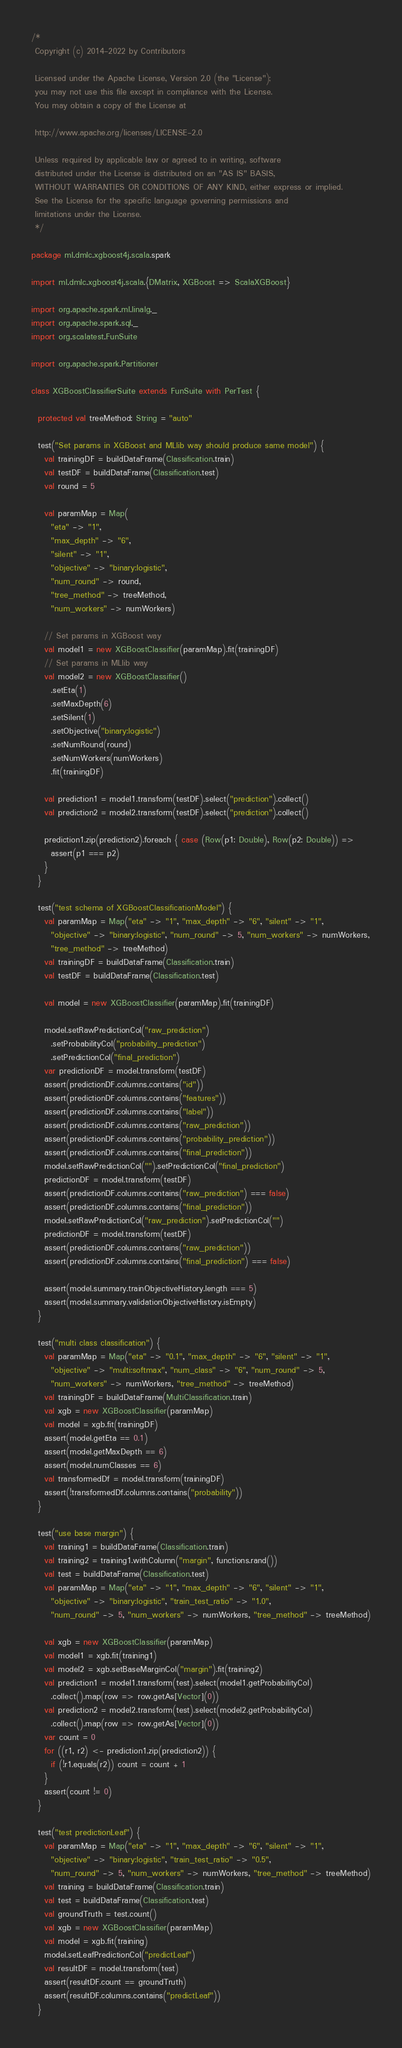<code> <loc_0><loc_0><loc_500><loc_500><_Scala_>/*
 Copyright (c) 2014-2022 by Contributors

 Licensed under the Apache License, Version 2.0 (the "License");
 you may not use this file except in compliance with the License.
 You may obtain a copy of the License at

 http://www.apache.org/licenses/LICENSE-2.0

 Unless required by applicable law or agreed to in writing, software
 distributed under the License is distributed on an "AS IS" BASIS,
 WITHOUT WARRANTIES OR CONDITIONS OF ANY KIND, either express or implied.
 See the License for the specific language governing permissions and
 limitations under the License.
 */

package ml.dmlc.xgboost4j.scala.spark

import ml.dmlc.xgboost4j.scala.{DMatrix, XGBoost => ScalaXGBoost}

import org.apache.spark.ml.linalg._
import org.apache.spark.sql._
import org.scalatest.FunSuite

import org.apache.spark.Partitioner

class XGBoostClassifierSuite extends FunSuite with PerTest {

  protected val treeMethod: String = "auto"

  test("Set params in XGBoost and MLlib way should produce same model") {
    val trainingDF = buildDataFrame(Classification.train)
    val testDF = buildDataFrame(Classification.test)
    val round = 5

    val paramMap = Map(
      "eta" -> "1",
      "max_depth" -> "6",
      "silent" -> "1",
      "objective" -> "binary:logistic",
      "num_round" -> round,
      "tree_method" -> treeMethod,
      "num_workers" -> numWorkers)

    // Set params in XGBoost way
    val model1 = new XGBoostClassifier(paramMap).fit(trainingDF)
    // Set params in MLlib way
    val model2 = new XGBoostClassifier()
      .setEta(1)
      .setMaxDepth(6)
      .setSilent(1)
      .setObjective("binary:logistic")
      .setNumRound(round)
      .setNumWorkers(numWorkers)
      .fit(trainingDF)

    val prediction1 = model1.transform(testDF).select("prediction").collect()
    val prediction2 = model2.transform(testDF).select("prediction").collect()

    prediction1.zip(prediction2).foreach { case (Row(p1: Double), Row(p2: Double)) =>
      assert(p1 === p2)
    }
  }

  test("test schema of XGBoostClassificationModel") {
    val paramMap = Map("eta" -> "1", "max_depth" -> "6", "silent" -> "1",
      "objective" -> "binary:logistic", "num_round" -> 5, "num_workers" -> numWorkers,
      "tree_method" -> treeMethod)
    val trainingDF = buildDataFrame(Classification.train)
    val testDF = buildDataFrame(Classification.test)

    val model = new XGBoostClassifier(paramMap).fit(trainingDF)

    model.setRawPredictionCol("raw_prediction")
      .setProbabilityCol("probability_prediction")
      .setPredictionCol("final_prediction")
    var predictionDF = model.transform(testDF)
    assert(predictionDF.columns.contains("id"))
    assert(predictionDF.columns.contains("features"))
    assert(predictionDF.columns.contains("label"))
    assert(predictionDF.columns.contains("raw_prediction"))
    assert(predictionDF.columns.contains("probability_prediction"))
    assert(predictionDF.columns.contains("final_prediction"))
    model.setRawPredictionCol("").setPredictionCol("final_prediction")
    predictionDF = model.transform(testDF)
    assert(predictionDF.columns.contains("raw_prediction") === false)
    assert(predictionDF.columns.contains("final_prediction"))
    model.setRawPredictionCol("raw_prediction").setPredictionCol("")
    predictionDF = model.transform(testDF)
    assert(predictionDF.columns.contains("raw_prediction"))
    assert(predictionDF.columns.contains("final_prediction") === false)

    assert(model.summary.trainObjectiveHistory.length === 5)
    assert(model.summary.validationObjectiveHistory.isEmpty)
  }

  test("multi class classification") {
    val paramMap = Map("eta" -> "0.1", "max_depth" -> "6", "silent" -> "1",
      "objective" -> "multi:softmax", "num_class" -> "6", "num_round" -> 5,
      "num_workers" -> numWorkers, "tree_method" -> treeMethod)
    val trainingDF = buildDataFrame(MultiClassification.train)
    val xgb = new XGBoostClassifier(paramMap)
    val model = xgb.fit(trainingDF)
    assert(model.getEta == 0.1)
    assert(model.getMaxDepth == 6)
    assert(model.numClasses == 6)
    val transformedDf = model.transform(trainingDF)
    assert(!transformedDf.columns.contains("probability"))
  }

  test("use base margin") {
    val training1 = buildDataFrame(Classification.train)
    val training2 = training1.withColumn("margin", functions.rand())
    val test = buildDataFrame(Classification.test)
    val paramMap = Map("eta" -> "1", "max_depth" -> "6", "silent" -> "1",
      "objective" -> "binary:logistic", "train_test_ratio" -> "1.0",
      "num_round" -> 5, "num_workers" -> numWorkers, "tree_method" -> treeMethod)

    val xgb = new XGBoostClassifier(paramMap)
    val model1 = xgb.fit(training1)
    val model2 = xgb.setBaseMarginCol("margin").fit(training2)
    val prediction1 = model1.transform(test).select(model1.getProbabilityCol)
      .collect().map(row => row.getAs[Vector](0))
    val prediction2 = model2.transform(test).select(model2.getProbabilityCol)
      .collect().map(row => row.getAs[Vector](0))
    var count = 0
    for ((r1, r2) <- prediction1.zip(prediction2)) {
      if (!r1.equals(r2)) count = count + 1
    }
    assert(count != 0)
  }

  test("test predictionLeaf") {
    val paramMap = Map("eta" -> "1", "max_depth" -> "6", "silent" -> "1",
      "objective" -> "binary:logistic", "train_test_ratio" -> "0.5",
      "num_round" -> 5, "num_workers" -> numWorkers, "tree_method" -> treeMethod)
    val training = buildDataFrame(Classification.train)
    val test = buildDataFrame(Classification.test)
    val groundTruth = test.count()
    val xgb = new XGBoostClassifier(paramMap)
    val model = xgb.fit(training)
    model.setLeafPredictionCol("predictLeaf")
    val resultDF = model.transform(test)
    assert(resultDF.count == groundTruth)
    assert(resultDF.columns.contains("predictLeaf"))
  }
</code> 